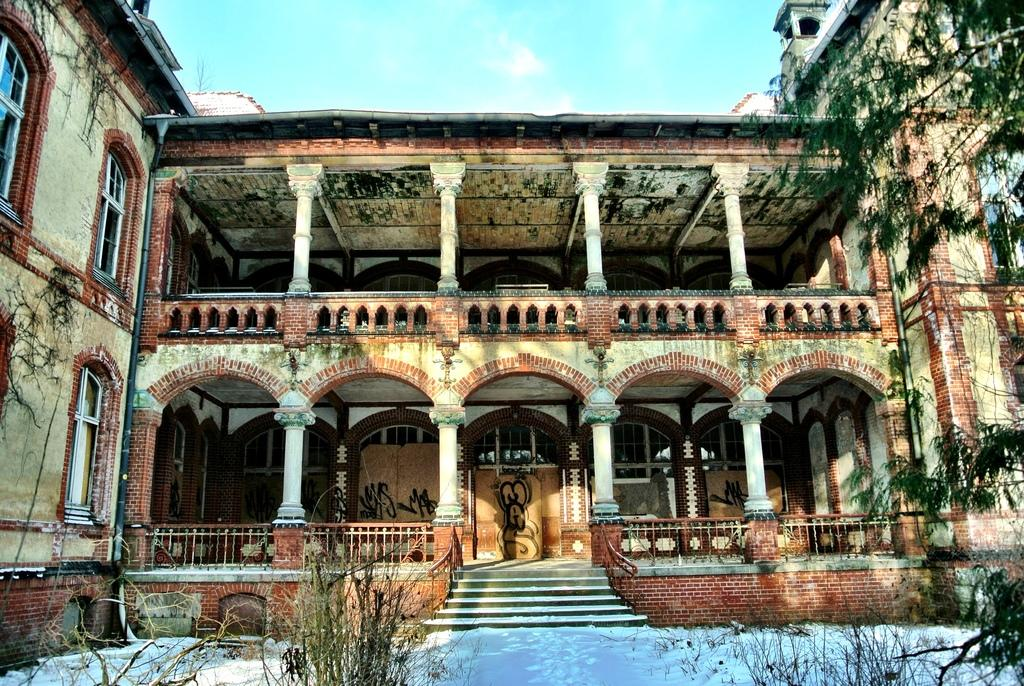What type of structure is present in the image? There is a building in the image. What architectural features can be seen on the building? The building has windows and pillars. What is the weather like in the image? There is snow visible in the image, indicating a cold or wintry condition. Are there any additional features present in the image? Yes, there are stairs and trees in the image. What can be seen in the sky in the image? The sky is visible in the image. What type of toothbrush is being used by the donkey in the image? There is no donkey or toothbrush present in the image. 